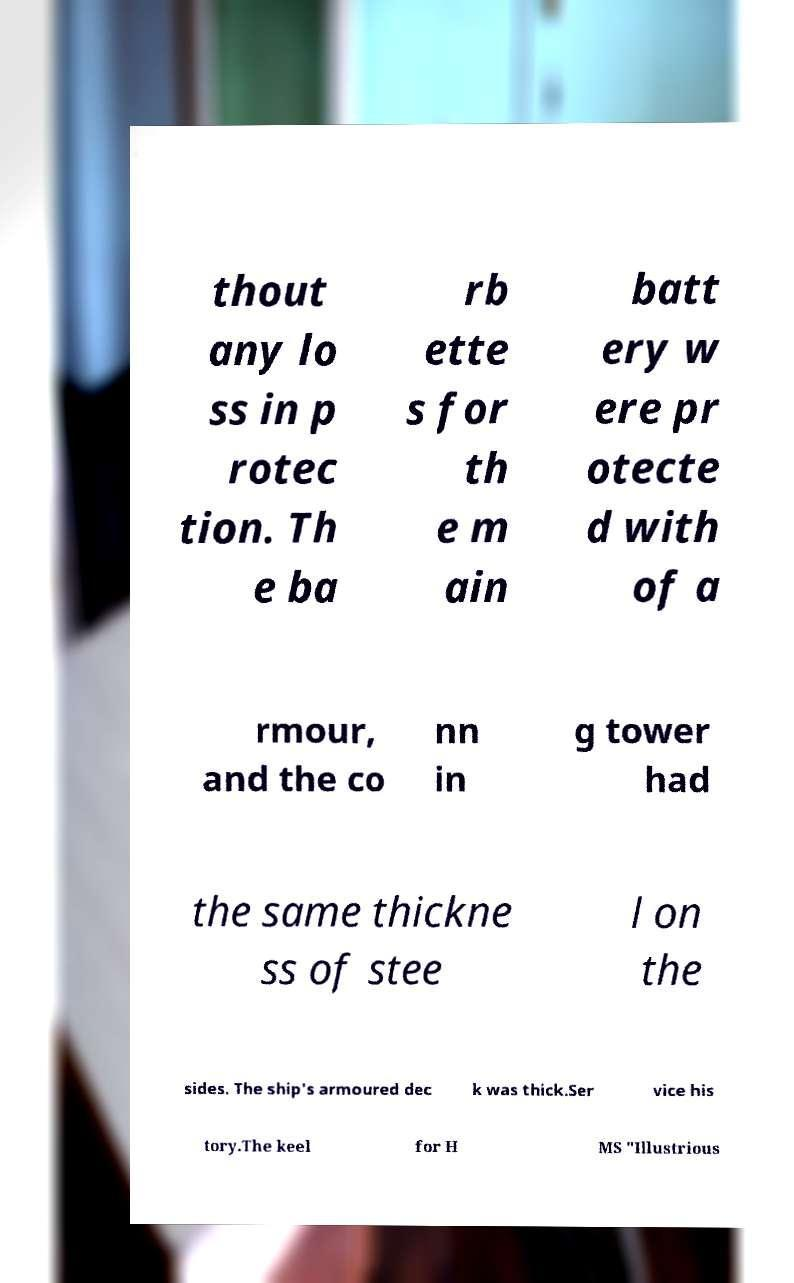Can you accurately transcribe the text from the provided image for me? thout any lo ss in p rotec tion. Th e ba rb ette s for th e m ain batt ery w ere pr otecte d with of a rmour, and the co nn in g tower had the same thickne ss of stee l on the sides. The ship's armoured dec k was thick.Ser vice his tory.The keel for H MS "Illustrious 